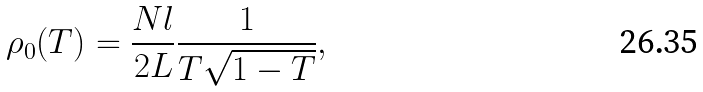<formula> <loc_0><loc_0><loc_500><loc_500>\rho _ { 0 } ( T ) = \frac { N l } { 2 L } \frac { 1 } { T \sqrt { 1 - T } } ,</formula> 